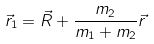<formula> <loc_0><loc_0><loc_500><loc_500>\vec { r } _ { 1 } = \vec { R } + \frac { m _ { 2 } } { m _ { 1 } + m _ { 2 } } \vec { r }</formula> 